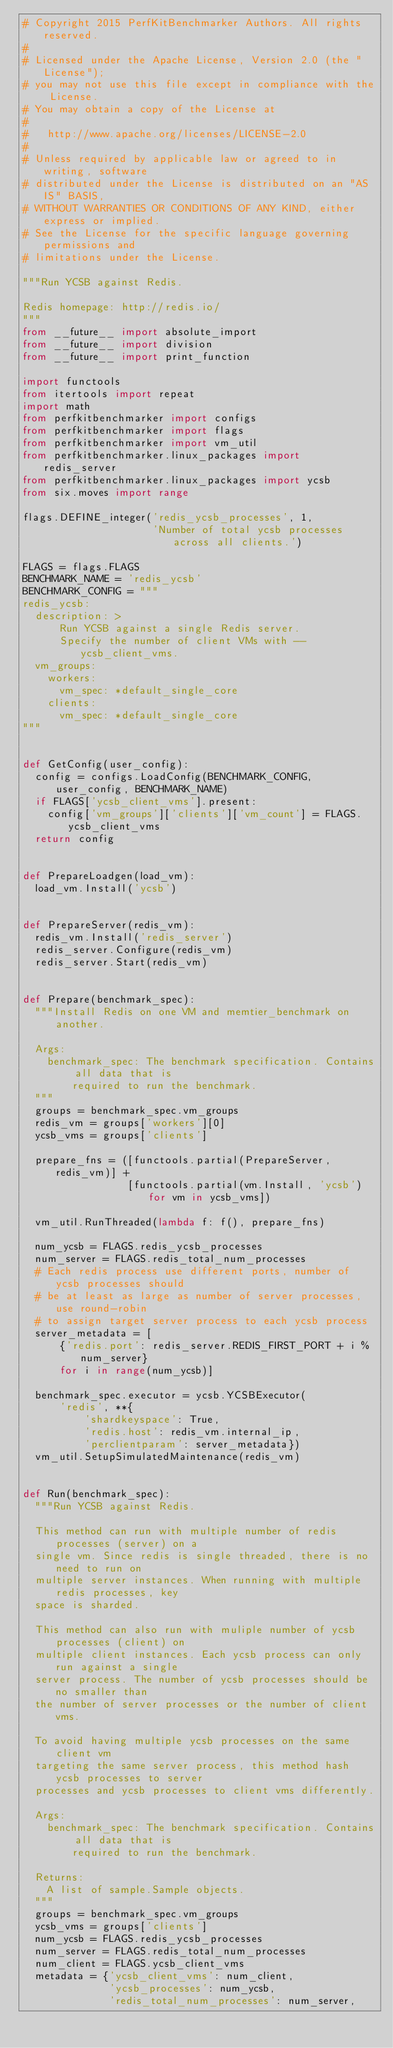<code> <loc_0><loc_0><loc_500><loc_500><_Python_># Copyright 2015 PerfKitBenchmarker Authors. All rights reserved.
#
# Licensed under the Apache License, Version 2.0 (the "License");
# you may not use this file except in compliance with the License.
# You may obtain a copy of the License at
#
#   http://www.apache.org/licenses/LICENSE-2.0
#
# Unless required by applicable law or agreed to in writing, software
# distributed under the License is distributed on an "AS IS" BASIS,
# WITHOUT WARRANTIES OR CONDITIONS OF ANY KIND, either express or implied.
# See the License for the specific language governing permissions and
# limitations under the License.

"""Run YCSB against Redis.

Redis homepage: http://redis.io/
"""
from __future__ import absolute_import
from __future__ import division
from __future__ import print_function

import functools
from itertools import repeat
import math
from perfkitbenchmarker import configs
from perfkitbenchmarker import flags
from perfkitbenchmarker import vm_util
from perfkitbenchmarker.linux_packages import redis_server
from perfkitbenchmarker.linux_packages import ycsb
from six.moves import range

flags.DEFINE_integer('redis_ycsb_processes', 1,
                     'Number of total ycsb processes across all clients.')

FLAGS = flags.FLAGS
BENCHMARK_NAME = 'redis_ycsb'
BENCHMARK_CONFIG = """
redis_ycsb:
  description: >
      Run YCSB against a single Redis server.
      Specify the number of client VMs with --ycsb_client_vms.
  vm_groups:
    workers:
      vm_spec: *default_single_core
    clients:
      vm_spec: *default_single_core
"""


def GetConfig(user_config):
  config = configs.LoadConfig(BENCHMARK_CONFIG, user_config, BENCHMARK_NAME)
  if FLAGS['ycsb_client_vms'].present:
    config['vm_groups']['clients']['vm_count'] = FLAGS.ycsb_client_vms
  return config


def PrepareLoadgen(load_vm):
  load_vm.Install('ycsb')


def PrepareServer(redis_vm):
  redis_vm.Install('redis_server')
  redis_server.Configure(redis_vm)
  redis_server.Start(redis_vm)


def Prepare(benchmark_spec):
  """Install Redis on one VM and memtier_benchmark on another.

  Args:
    benchmark_spec: The benchmark specification. Contains all data that is
        required to run the benchmark.
  """
  groups = benchmark_spec.vm_groups
  redis_vm = groups['workers'][0]
  ycsb_vms = groups['clients']

  prepare_fns = ([functools.partial(PrepareServer, redis_vm)] +
                 [functools.partial(vm.Install, 'ycsb') for vm in ycsb_vms])

  vm_util.RunThreaded(lambda f: f(), prepare_fns)

  num_ycsb = FLAGS.redis_ycsb_processes
  num_server = FLAGS.redis_total_num_processes
  # Each redis process use different ports, number of ycsb processes should
  # be at least as large as number of server processes, use round-robin
  # to assign target server process to each ycsb process
  server_metadata = [
      {'redis.port': redis_server.REDIS_FIRST_PORT + i % num_server}
      for i in range(num_ycsb)]

  benchmark_spec.executor = ycsb.YCSBExecutor(
      'redis', **{
          'shardkeyspace': True,
          'redis.host': redis_vm.internal_ip,
          'perclientparam': server_metadata})
  vm_util.SetupSimulatedMaintenance(redis_vm)


def Run(benchmark_spec):
  """Run YCSB against Redis.

  This method can run with multiple number of redis processes (server) on a
  single vm. Since redis is single threaded, there is no need to run on
  multiple server instances. When running with multiple redis processes, key
  space is sharded.

  This method can also run with muliple number of ycsb processes (client) on
  multiple client instances. Each ycsb process can only run against a single
  server process. The number of ycsb processes should be no smaller than
  the number of server processes or the number of client vms.

  To avoid having multiple ycsb processes on the same client vm
  targeting the same server process, this method hash ycsb processes to server
  processes and ycsb processes to client vms differently.

  Args:
    benchmark_spec: The benchmark specification. Contains all data that is
        required to run the benchmark.

  Returns:
    A list of sample.Sample objects.
  """
  groups = benchmark_spec.vm_groups
  ycsb_vms = groups['clients']
  num_ycsb = FLAGS.redis_ycsb_processes
  num_server = FLAGS.redis_total_num_processes
  num_client = FLAGS.ycsb_client_vms
  metadata = {'ycsb_client_vms': num_client,
              'ycsb_processes': num_ycsb,
              'redis_total_num_processes': num_server,</code> 